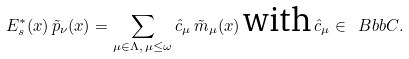Convert formula to latex. <formula><loc_0><loc_0><loc_500><loc_500>E ^ { * } _ { s } ( x ) \, \tilde { p } _ { \nu } ( x ) = \sum _ { \mu \in \Lambda , \, \mu \leq \omega } \hat { c } _ { \mu } \, \tilde { m } _ { \mu } ( x ) \, \text {with} \, \hat { c } _ { \mu } \in { \ B b b C } .</formula> 